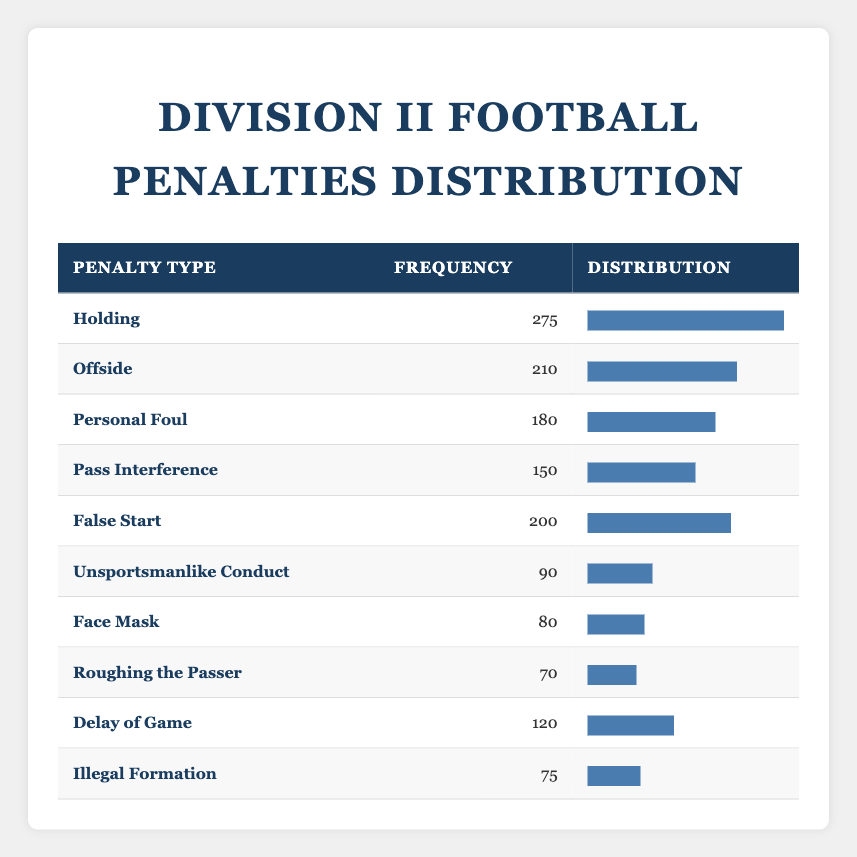What is the penalty type with the highest frequency? The highest frequency listed in the table is for the type "Holding," which has a frequency of 275.
Answer: Holding How many total penalties were recorded in the last five years? To find the total penalties, we sum all the frequencies: 275 + 210 + 180 + 150 + 200 + 90 + 80 + 70 + 120 + 75 = 1,470.
Answer: 1470 What percentage of total penalties do "Personal Foul" penalties represent? The frequency for "Personal Foul" is 180. First, we find the total penalties, which we determined to be 1,470. Next, we calculate the percentage: (180/1470) * 100 = approximately 12.24%.
Answer: 12.24% Is the number of "Unsportsmanlike Conduct" penalties less than that for "Face Mask" penalties? "Unsportsmanlike Conduct" has a frequency of 90, while "Face Mask" has a frequency of 80. Since 90 is greater than 80, the statement is false.
Answer: No How many more penalties were called for "Offside" compared to "Roughing the Passer"? The frequency of "Offside" is 210 and for "Roughing the Passer" it is 70. We calculate the difference: 210 - 70 = 140.
Answer: 140 What is the average frequency of penalties for the types listed? To find the average, we first determine the total penalties (1,470) and divide it by the number of penalty types (10): 1,470 / 10 = 147.
Answer: 147 Which penalty type has the lowest frequency and what is that frequency? The lowest frequency in the table is for "Roughing the Passer," which has a frequency of 70.
Answer: Roughing the Passer, 70 How many penalty types have a frequency greater than 100? The types with frequencies greater than 100 are "Holding," "Offside," "Personal Foul," "False Start," and "Delay of Game." Counting these types gives us five.
Answer: 5 